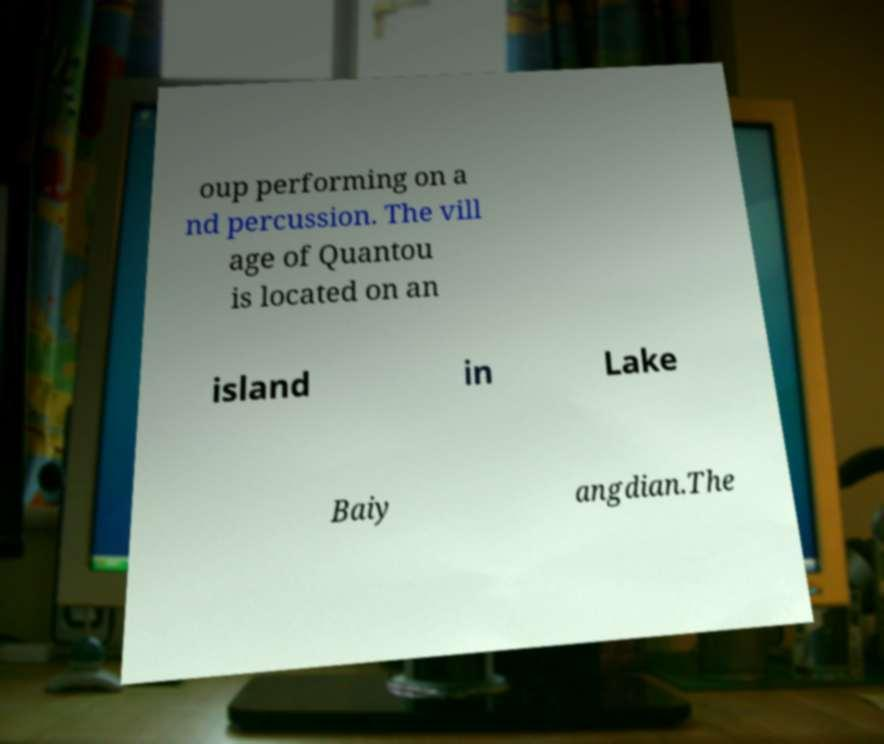There's text embedded in this image that I need extracted. Can you transcribe it verbatim? oup performing on a nd percussion. The vill age of Quantou is located on an island in Lake Baiy angdian.The 